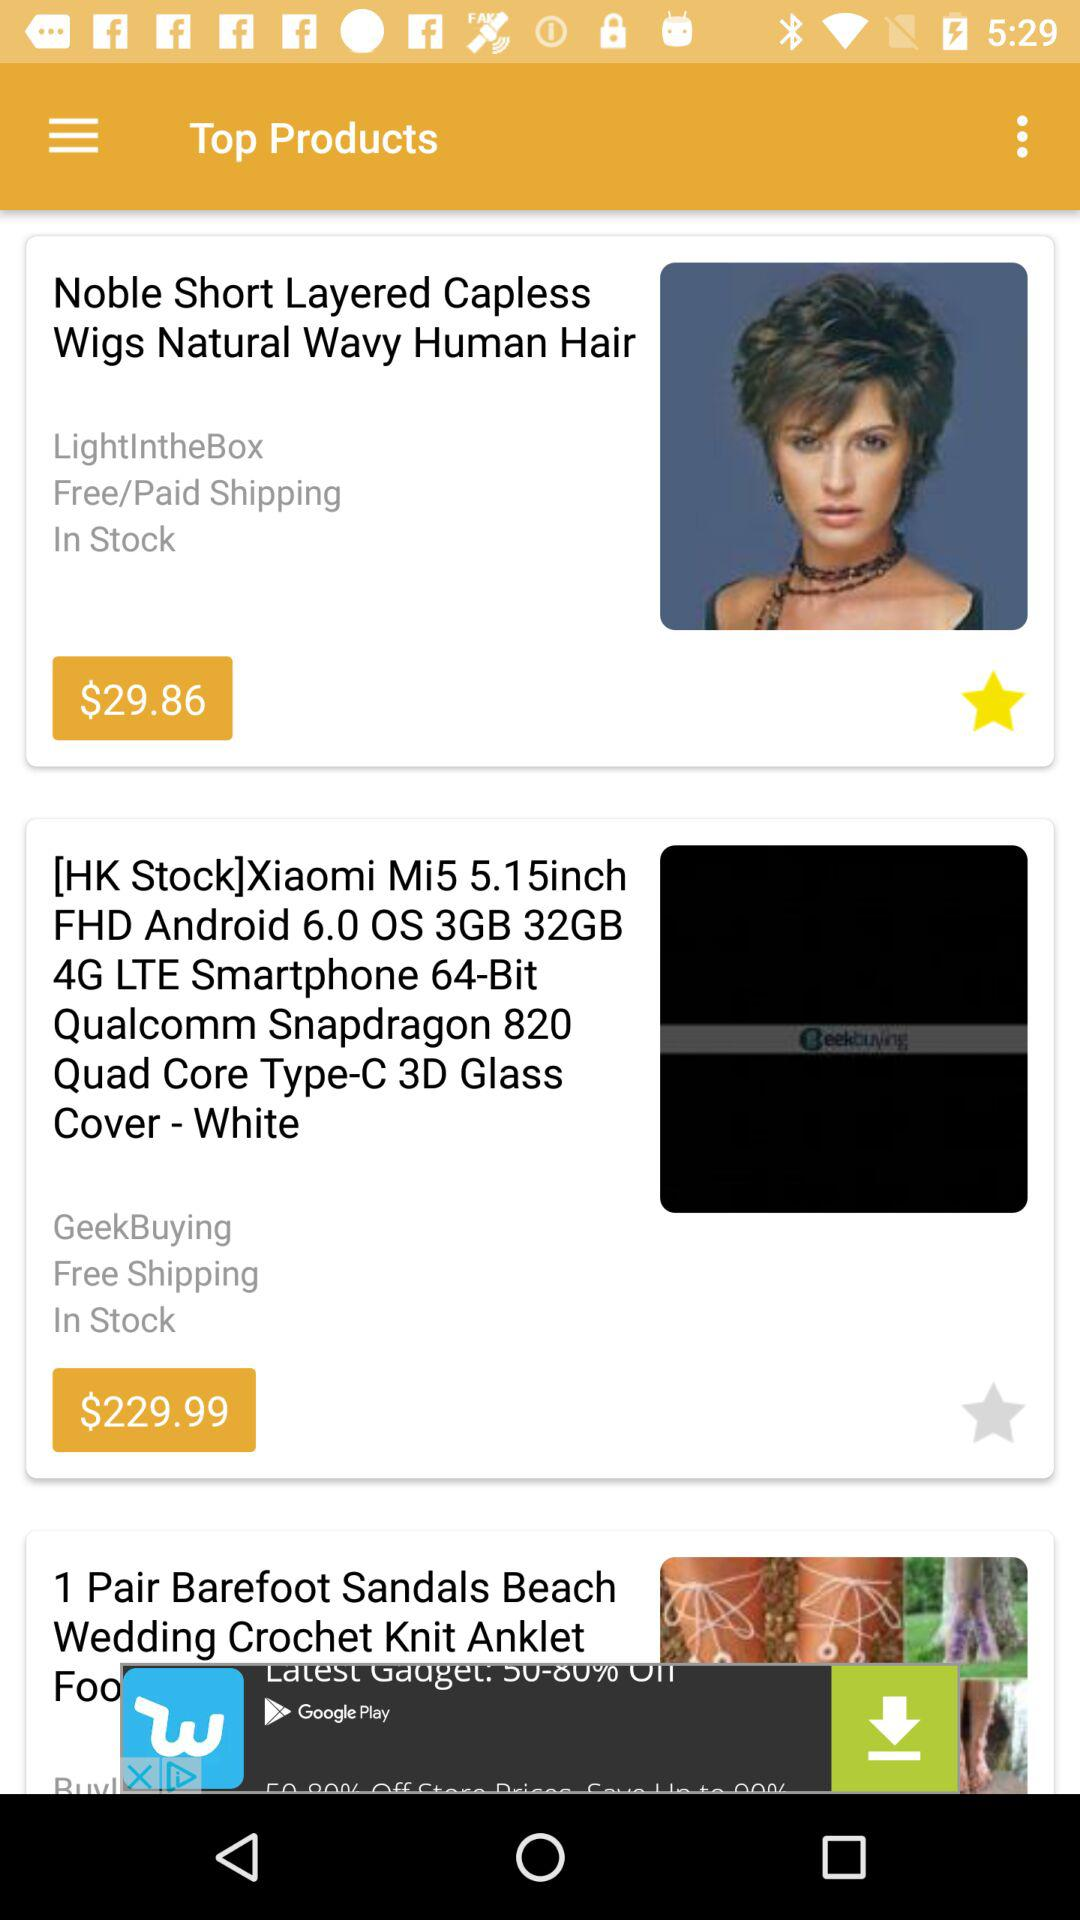Which product is marked as a favourite? The product that is marked as a favourite is "Noble Short Layered Capless Wigs Natural Wavy Human Hair". 